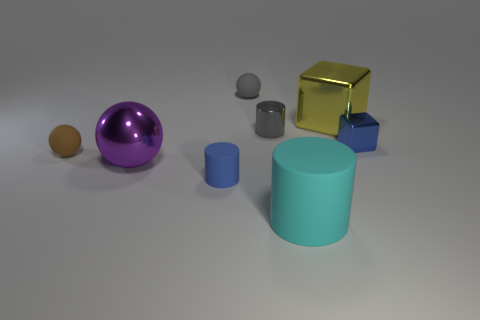Add 2 tiny brown rubber balls. How many objects exist? 10 Subtract all small matte spheres. How many spheres are left? 1 Subtract all blocks. How many objects are left? 6 Subtract 0 cyan cubes. How many objects are left? 8 Subtract all purple balls. Subtract all big purple objects. How many objects are left? 6 Add 1 big purple balls. How many big purple balls are left? 2 Add 7 cyan matte things. How many cyan matte things exist? 8 